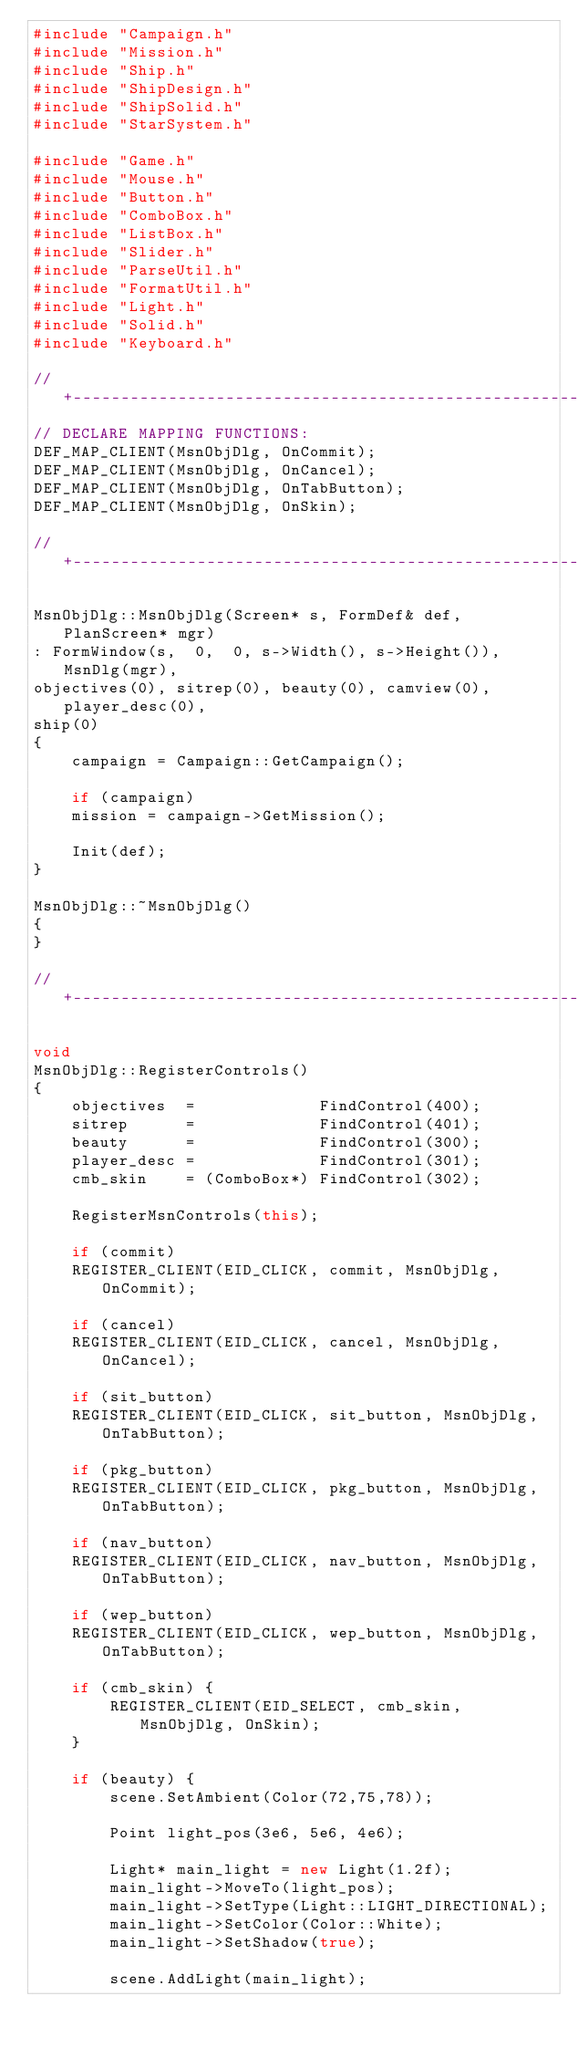Convert code to text. <code><loc_0><loc_0><loc_500><loc_500><_C++_>#include "Campaign.h"
#include "Mission.h"
#include "Ship.h"
#include "ShipDesign.h"
#include "ShipSolid.h"
#include "StarSystem.h"

#include "Game.h"
#include "Mouse.h"
#include "Button.h"
#include "ComboBox.h"
#include "ListBox.h"
#include "Slider.h"
#include "ParseUtil.h"
#include "FormatUtil.h"
#include "Light.h"
#include "Solid.h"
#include "Keyboard.h"

// +--------------------------------------------------------------------+
// DECLARE MAPPING FUNCTIONS:
DEF_MAP_CLIENT(MsnObjDlg, OnCommit);
DEF_MAP_CLIENT(MsnObjDlg, OnCancel);
DEF_MAP_CLIENT(MsnObjDlg, OnTabButton);
DEF_MAP_CLIENT(MsnObjDlg, OnSkin);

// +--------------------------------------------------------------------+

MsnObjDlg::MsnObjDlg(Screen* s, FormDef& def, PlanScreen* mgr)
: FormWindow(s,  0,  0, s->Width(), s->Height()), MsnDlg(mgr),
objectives(0), sitrep(0), beauty(0), camview(0), player_desc(0),
ship(0)
{
    campaign = Campaign::GetCampaign();

    if (campaign)
    mission = campaign->GetMission();

    Init(def);
}

MsnObjDlg::~MsnObjDlg()
{
}

// +--------------------------------------------------------------------+

void
MsnObjDlg::RegisterControls()
{
    objectives  =             FindControl(400);
    sitrep      =             FindControl(401);
    beauty      =             FindControl(300);
    player_desc =             FindControl(301);
    cmb_skin    = (ComboBox*) FindControl(302);

    RegisterMsnControls(this);

    if (commit)
    REGISTER_CLIENT(EID_CLICK, commit, MsnObjDlg, OnCommit);

    if (cancel)
    REGISTER_CLIENT(EID_CLICK, cancel, MsnObjDlg, OnCancel);

    if (sit_button)
    REGISTER_CLIENT(EID_CLICK, sit_button, MsnObjDlg, OnTabButton);

    if (pkg_button)
    REGISTER_CLIENT(EID_CLICK, pkg_button, MsnObjDlg, OnTabButton);

    if (nav_button)
    REGISTER_CLIENT(EID_CLICK, nav_button, MsnObjDlg, OnTabButton);

    if (wep_button)
    REGISTER_CLIENT(EID_CLICK, wep_button, MsnObjDlg, OnTabButton);

    if (cmb_skin) {
        REGISTER_CLIENT(EID_SELECT, cmb_skin,  MsnObjDlg, OnSkin);
    }

    if (beauty) {
        scene.SetAmbient(Color(72,75,78));

        Point light_pos(3e6, 5e6, 4e6);

        Light* main_light = new Light(1.2f);
        main_light->MoveTo(light_pos);
        main_light->SetType(Light::LIGHT_DIRECTIONAL);
        main_light->SetColor(Color::White);
        main_light->SetShadow(true);

        scene.AddLight(main_light);
</code> 